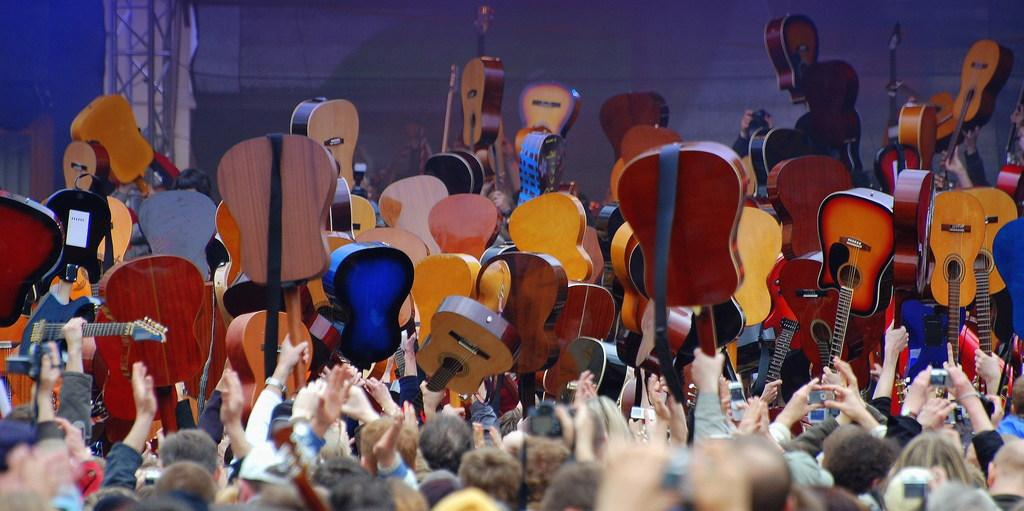What is the main subject in the foreground of the image? There is a crowd in the foreground of the image. What are the persons in the background of the image doing? They are holding guitars in the air in the background of the image. What architectural feature can be seen in the background of the image? There is a pillar in the background of the image. What type of fabric is present in the background of the image? There is a curtain in the background of the image. What type of gold snails can be seen crawling on the curtain in the image? There are no snails, gold or otherwise, present in the image. The curtain is not mentioned as having any snails on it. 